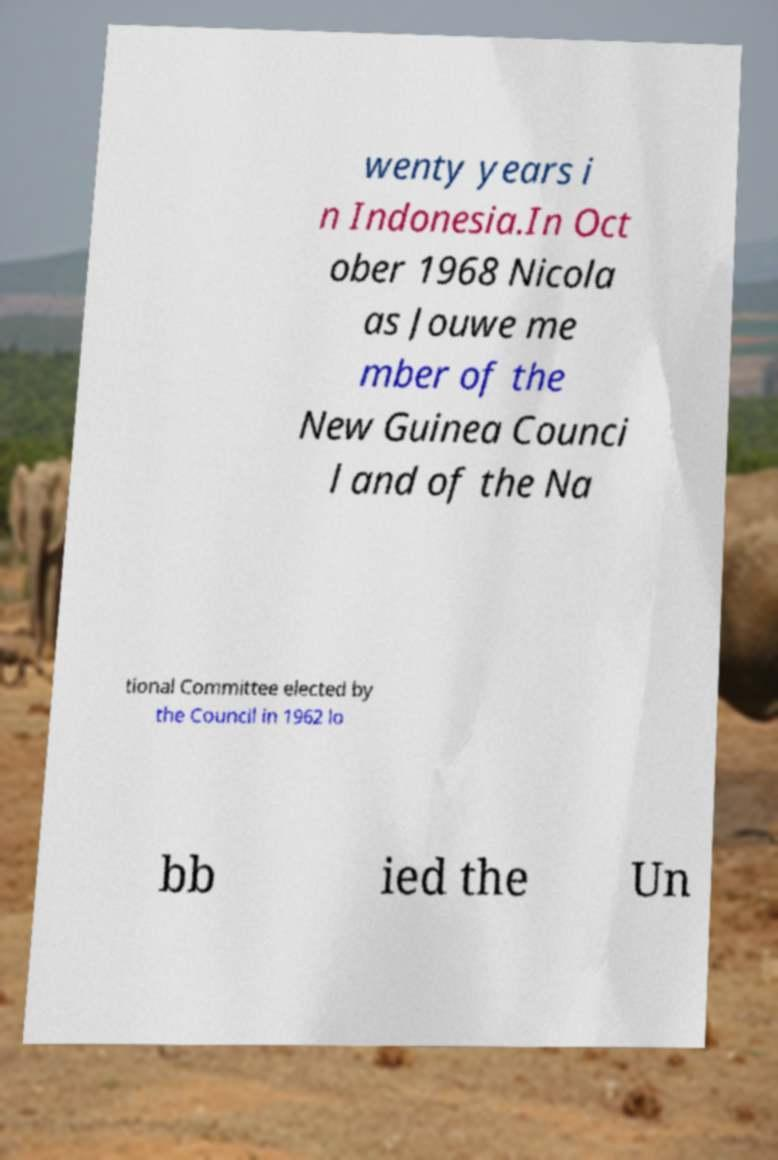There's text embedded in this image that I need extracted. Can you transcribe it verbatim? wenty years i n Indonesia.In Oct ober 1968 Nicola as Jouwe me mber of the New Guinea Counci l and of the Na tional Committee elected by the Council in 1962 lo bb ied the Un 